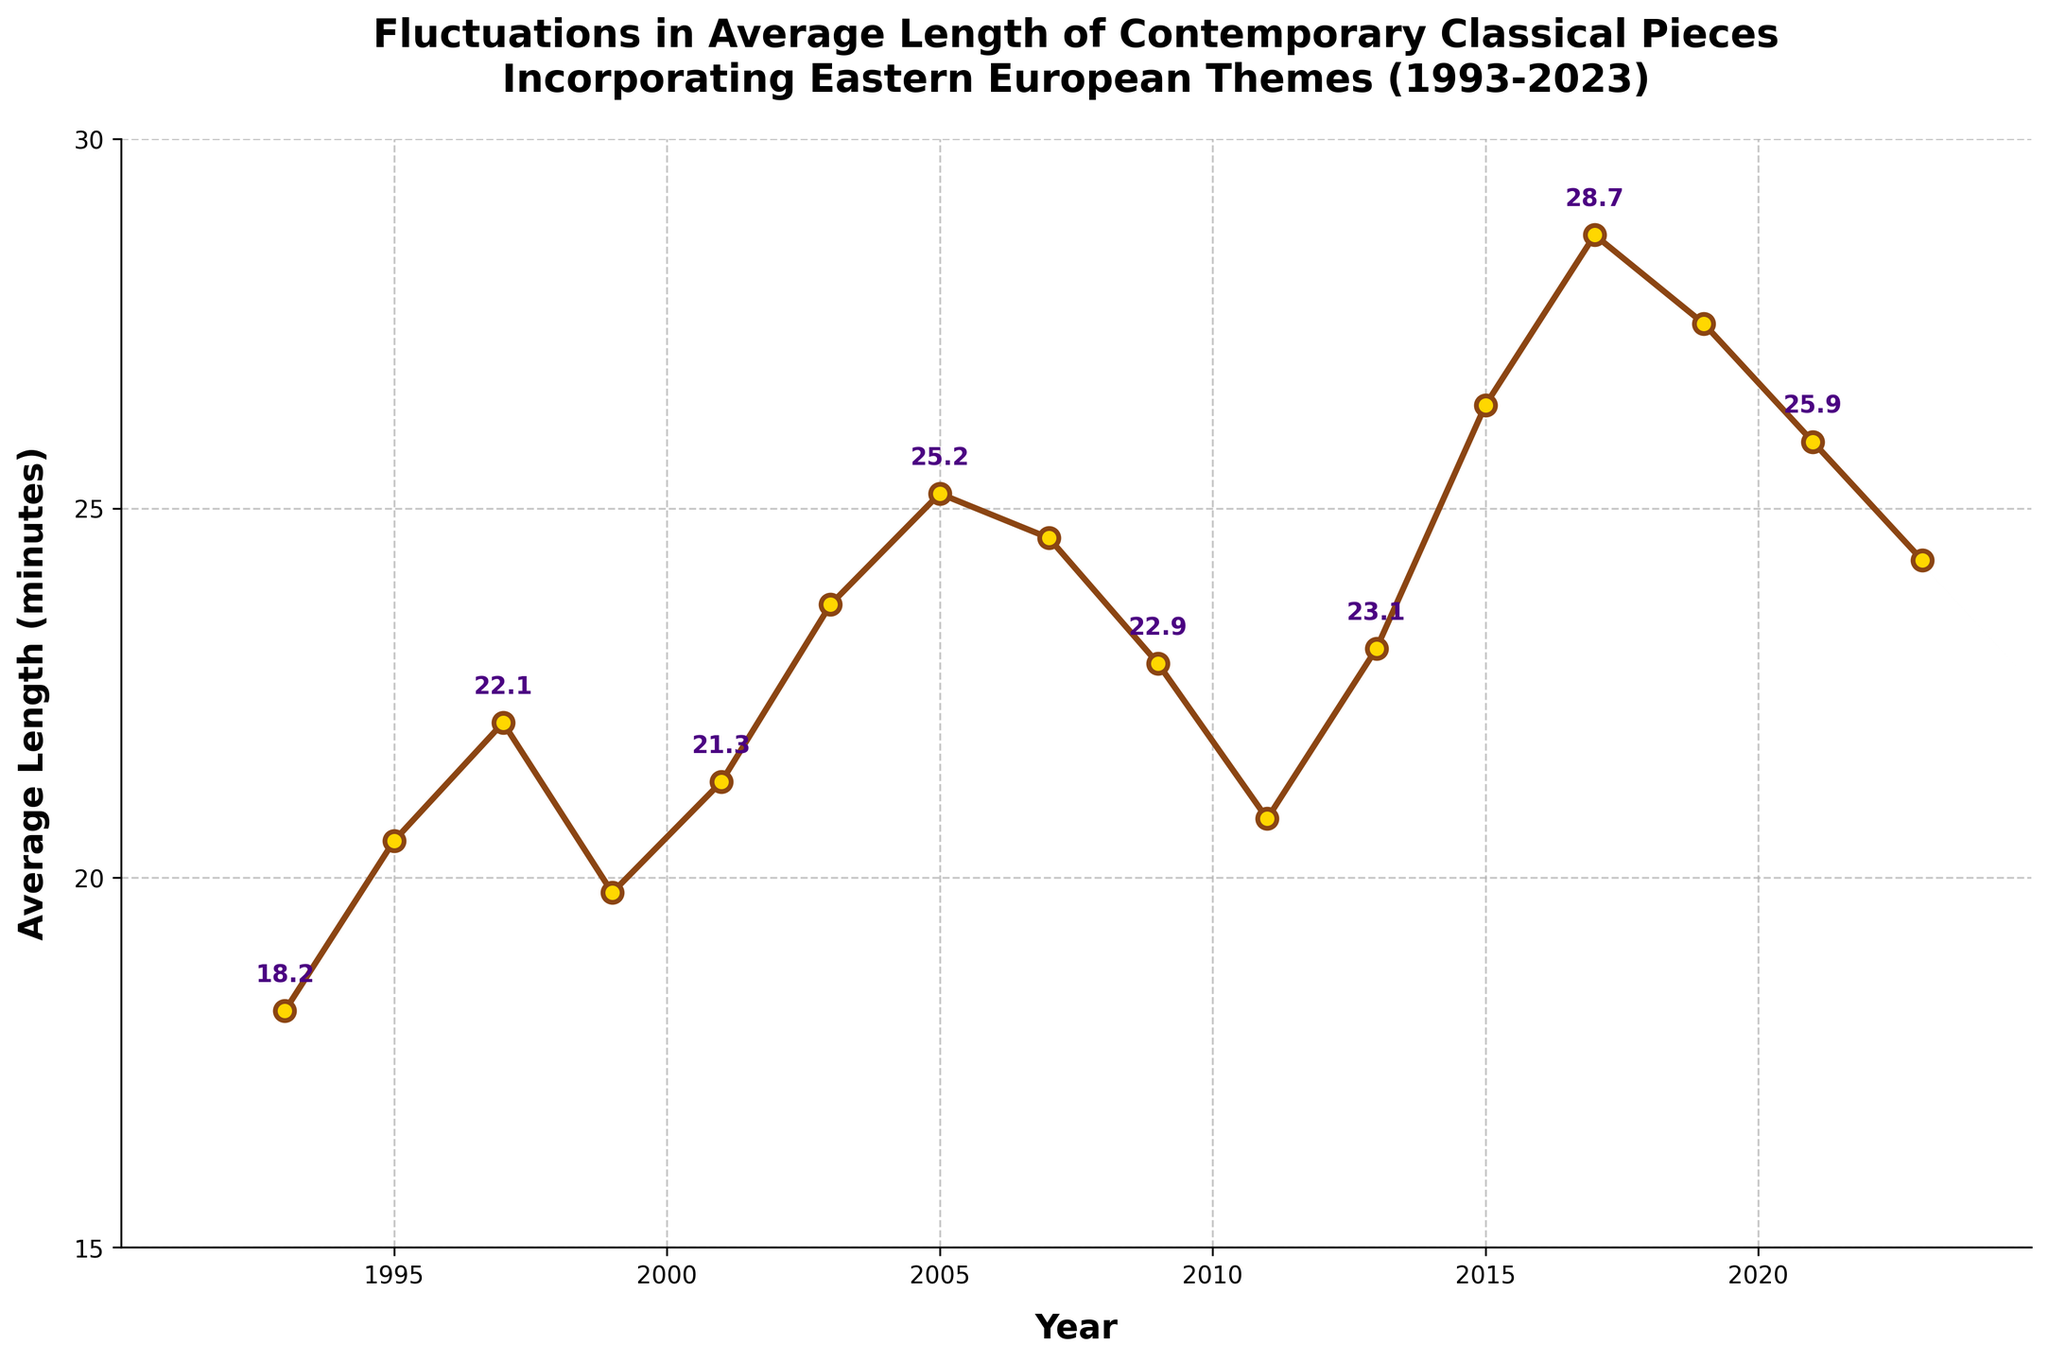Which year had the longest average length of contemporary classical pieces incorporating Eastern European themes? Based on the line chart, the year with the highest average length is the one with the peak point. The highest point occurs in 2017.
Answer: 2017 What is the difference in average length between 1993 and 2015? To find the difference, subtract the average length in 1993 from the average length in 2015. The lengths are 26.4 and 18.2 minutes, respectively. 26.4 - 18.2 = 8.2
Answer: 8.2 minutes How many years show a decreasing trend in the average length compared to the previous year? To determine this, compare each year’s average length with the previous year. The years where the average length decreased are 1999 < 1997, 2007 < 2005, 2009 < 2007, 2011 < 2009, 2019 < 2017, and 2023 < 2021. This results in six years with a decreasing trend.
Answer: 6 years What is the average length of compositions in 2003 and 2011 combined? To find the combined average, sum the lengths in 2003 and 2011, then divide by 2. The lengths are 23.7 and 20.8 minutes. (23.7 + 20.8) / 2 = 22.25
Answer: 22.25 minutes What visual element indicates a turning point or peak in the graph? Peaks or turning points are visually indicated by the markers at the apexes of the lines. The peak is at the highest marker, which is in 2017.
Answer: Marker at the apex Which period shows the most consistent increase in the average length of compositions? To identify the most consistent increase, look for the longest stretch of consecutive years where the line trend is upward without a decline. The period from 2011 to 2017 shows a steady increase in length.
Answer: 2011-2017 How does the average length in 1999 compare to that in 2001? Compare the values for the years 1999 and 2001 directly. The value in 1999 is 19.8 minutes, and in 2001 it is 21.3 minutes. Therefore, 2001 is greater than 1999.
Answer: 2001 is greater What is the average length across all years in the dataset? To find the overall average, sum all the average lengths and divide by the number of years (16 years). (18.2+20.5+22.1+19.8+21.3+23.7+25.2+24.6+22.9+20.8+23.1+26.4+28.7+27.5+25.9+24.3) / 16 = 23.42
Answer: 23.42 minutes Which two consecutive years have the greatest increase in average length? Find the pair of consecutive years with the largest increase by comparing the differences year-over-year. The largest increase is from 2015 to 2017 (28.7 - 26.4 = 2.3 minutes).
Answer: 2015 to 2017 